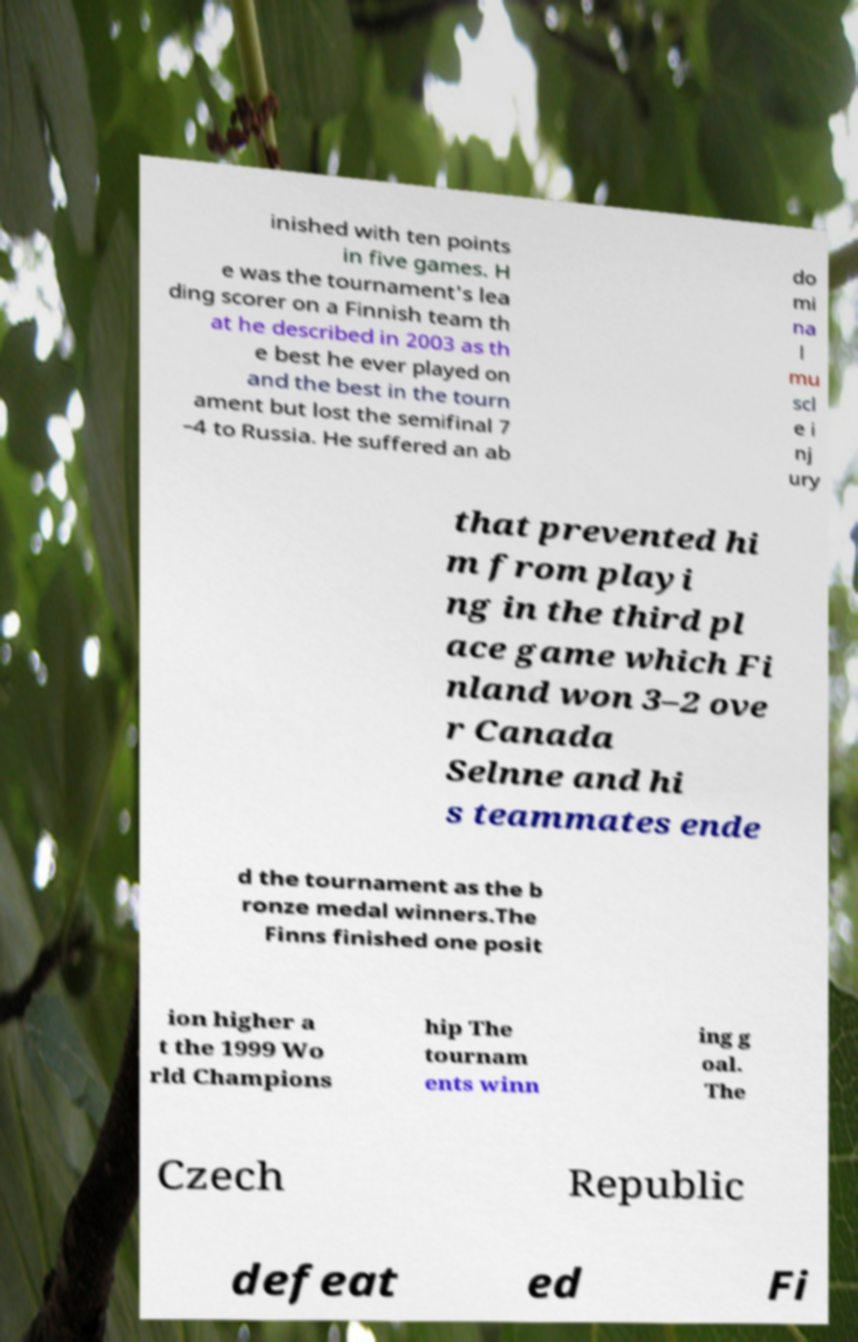Can you read and provide the text displayed in the image?This photo seems to have some interesting text. Can you extract and type it out for me? inished with ten points in five games. H e was the tournament's lea ding scorer on a Finnish team th at he described in 2003 as th e best he ever played on and the best in the tourn ament but lost the semifinal 7 –4 to Russia. He suffered an ab do mi na l mu scl e i nj ury that prevented hi m from playi ng in the third pl ace game which Fi nland won 3–2 ove r Canada Selnne and hi s teammates ende d the tournament as the b ronze medal winners.The Finns finished one posit ion higher a t the 1999 Wo rld Champions hip The tournam ents winn ing g oal. The Czech Republic defeat ed Fi 